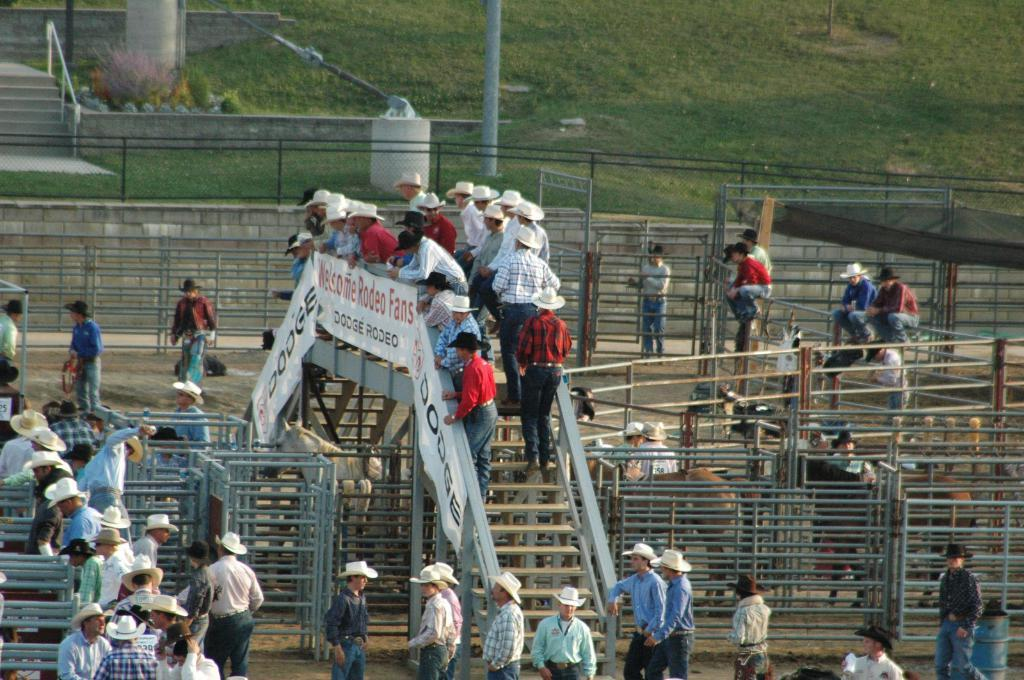What type of structure can be seen in the image? There are stairs in the image. What material are the rods made of in the image? Iron rods are present in the image. What decorative elements are visible in the image? Banners are visible in the image. Can you describe the people in the image? There are people in the image. What type of barrier is present in the image? A fence is present in the image. What type of vegetation can be seen in the image? Grass is visible in the image. What type of sand can be seen on the pickle in the image? There is no sand or pickle present in the image. Who needs to give approval for the event in the image? There is no event or approval process mentioned in the image. 